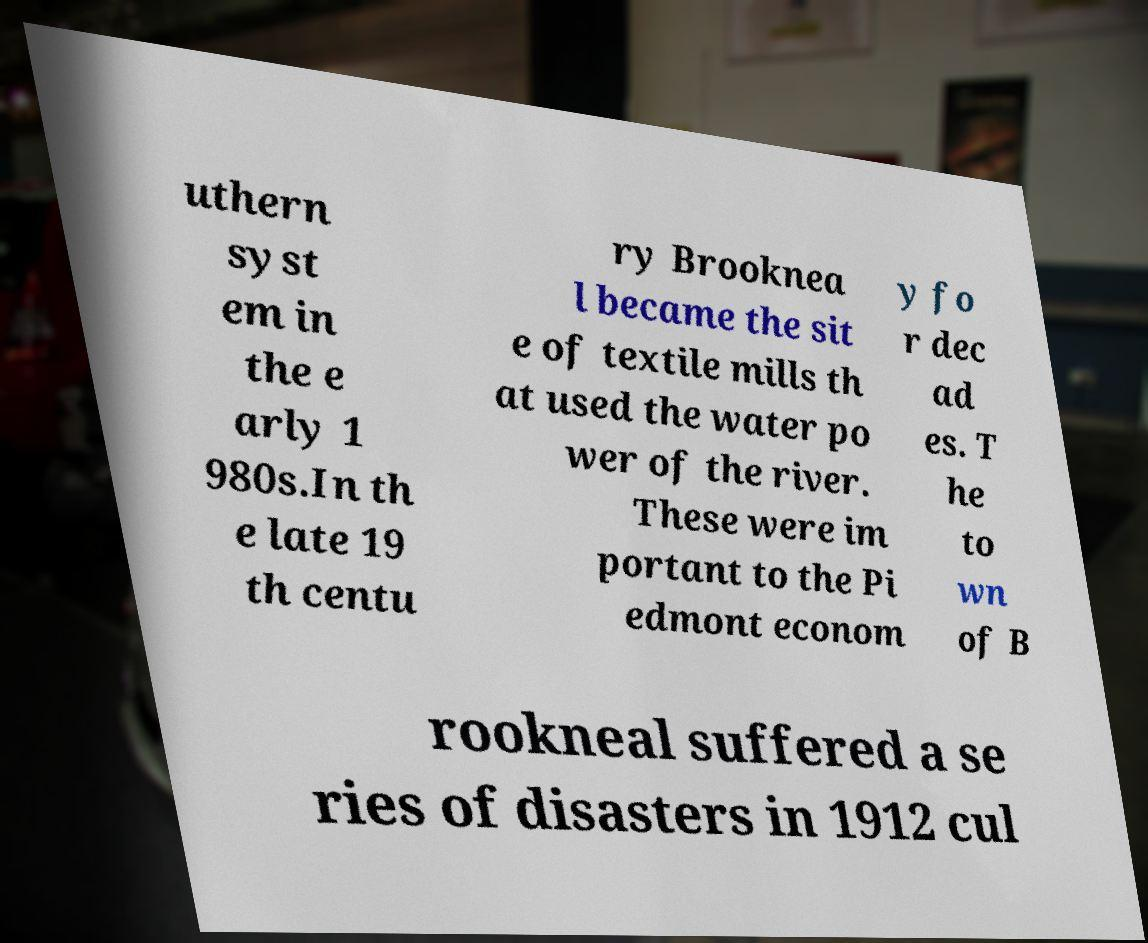Could you assist in decoding the text presented in this image and type it out clearly? uthern syst em in the e arly 1 980s.In th e late 19 th centu ry Brooknea l became the sit e of textile mills th at used the water po wer of the river. These were im portant to the Pi edmont econom y fo r dec ad es. T he to wn of B rookneal suffered a se ries of disasters in 1912 cul 